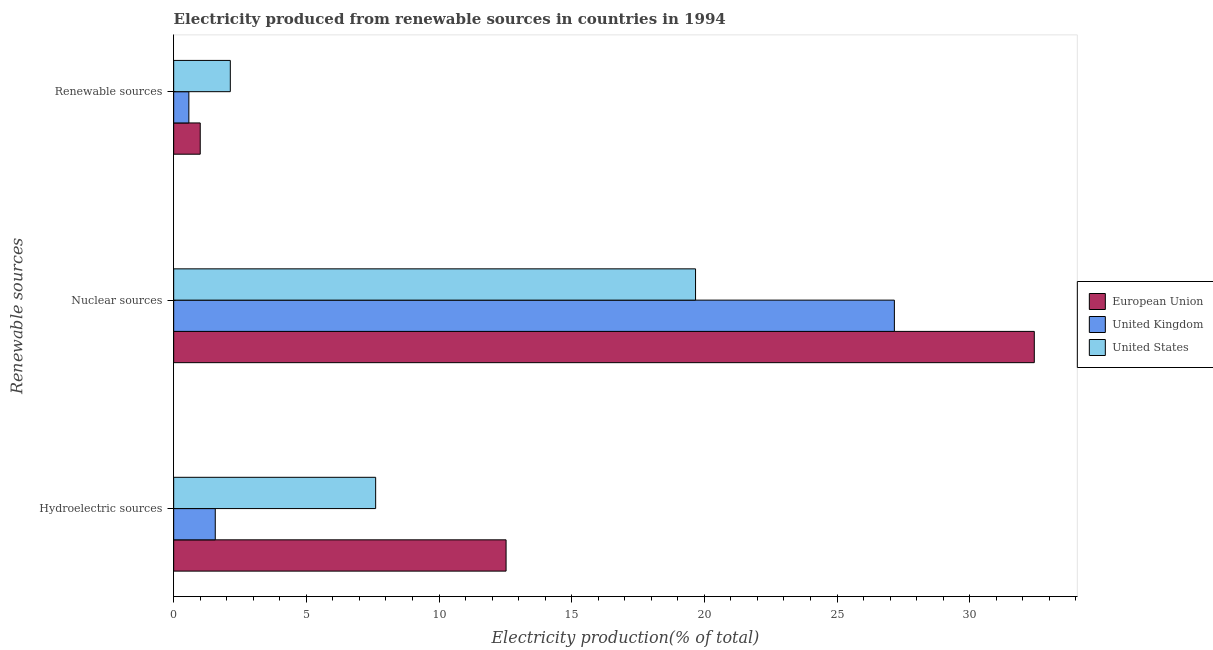How many bars are there on the 1st tick from the top?
Keep it short and to the point. 3. How many bars are there on the 1st tick from the bottom?
Your response must be concise. 3. What is the label of the 1st group of bars from the top?
Give a very brief answer. Renewable sources. What is the percentage of electricity produced by renewable sources in European Union?
Keep it short and to the point. 1. Across all countries, what is the maximum percentage of electricity produced by renewable sources?
Provide a succinct answer. 2.13. Across all countries, what is the minimum percentage of electricity produced by renewable sources?
Give a very brief answer. 0.57. In which country was the percentage of electricity produced by renewable sources maximum?
Your answer should be very brief. United States. What is the total percentage of electricity produced by nuclear sources in the graph?
Your answer should be compact. 79.27. What is the difference between the percentage of electricity produced by hydroelectric sources in United States and that in European Union?
Offer a very short reply. -4.92. What is the difference between the percentage of electricity produced by hydroelectric sources in United States and the percentage of electricity produced by renewable sources in United Kingdom?
Make the answer very short. 7.04. What is the average percentage of electricity produced by hydroelectric sources per country?
Your answer should be very brief. 7.24. What is the difference between the percentage of electricity produced by renewable sources and percentage of electricity produced by hydroelectric sources in United Kingdom?
Provide a succinct answer. -0.99. What is the ratio of the percentage of electricity produced by renewable sources in United States to that in European Union?
Your response must be concise. 2.13. What is the difference between the highest and the second highest percentage of electricity produced by hydroelectric sources?
Provide a short and direct response. 4.92. What is the difference between the highest and the lowest percentage of electricity produced by hydroelectric sources?
Your response must be concise. 10.96. What does the 3rd bar from the top in Nuclear sources represents?
Provide a succinct answer. European Union. What does the 2nd bar from the bottom in Nuclear sources represents?
Your response must be concise. United Kingdom. Are all the bars in the graph horizontal?
Make the answer very short. Yes. What is the difference between two consecutive major ticks on the X-axis?
Keep it short and to the point. 5. Are the values on the major ticks of X-axis written in scientific E-notation?
Offer a very short reply. No. Does the graph contain any zero values?
Ensure brevity in your answer.  No. How are the legend labels stacked?
Make the answer very short. Vertical. What is the title of the graph?
Your answer should be compact. Electricity produced from renewable sources in countries in 1994. Does "Iceland" appear as one of the legend labels in the graph?
Offer a terse response. No. What is the label or title of the Y-axis?
Your response must be concise. Renewable sources. What is the Electricity production(% of total) in European Union in Hydroelectric sources?
Provide a succinct answer. 12.53. What is the Electricity production(% of total) in United Kingdom in Hydroelectric sources?
Offer a terse response. 1.57. What is the Electricity production(% of total) in United States in Hydroelectric sources?
Provide a short and direct response. 7.61. What is the Electricity production(% of total) of European Union in Nuclear sources?
Provide a short and direct response. 32.44. What is the Electricity production(% of total) in United Kingdom in Nuclear sources?
Give a very brief answer. 27.16. What is the Electricity production(% of total) in United States in Nuclear sources?
Your response must be concise. 19.67. What is the Electricity production(% of total) in European Union in Renewable sources?
Provide a succinct answer. 1. What is the Electricity production(% of total) in United Kingdom in Renewable sources?
Your answer should be very brief. 0.57. What is the Electricity production(% of total) in United States in Renewable sources?
Provide a short and direct response. 2.13. Across all Renewable sources, what is the maximum Electricity production(% of total) in European Union?
Keep it short and to the point. 32.44. Across all Renewable sources, what is the maximum Electricity production(% of total) in United Kingdom?
Keep it short and to the point. 27.16. Across all Renewable sources, what is the maximum Electricity production(% of total) in United States?
Your response must be concise. 19.67. Across all Renewable sources, what is the minimum Electricity production(% of total) of European Union?
Provide a succinct answer. 1. Across all Renewable sources, what is the minimum Electricity production(% of total) in United Kingdom?
Make the answer very short. 0.57. Across all Renewable sources, what is the minimum Electricity production(% of total) in United States?
Give a very brief answer. 2.13. What is the total Electricity production(% of total) of European Union in the graph?
Ensure brevity in your answer.  45.96. What is the total Electricity production(% of total) of United Kingdom in the graph?
Offer a terse response. 29.3. What is the total Electricity production(% of total) of United States in the graph?
Your response must be concise. 29.42. What is the difference between the Electricity production(% of total) in European Union in Hydroelectric sources and that in Nuclear sources?
Ensure brevity in your answer.  -19.91. What is the difference between the Electricity production(% of total) of United Kingdom in Hydroelectric sources and that in Nuclear sources?
Offer a terse response. -25.59. What is the difference between the Electricity production(% of total) of United States in Hydroelectric sources and that in Nuclear sources?
Your response must be concise. -12.06. What is the difference between the Electricity production(% of total) in European Union in Hydroelectric sources and that in Renewable sources?
Keep it short and to the point. 11.53. What is the difference between the Electricity production(% of total) in United States in Hydroelectric sources and that in Renewable sources?
Your answer should be compact. 5.48. What is the difference between the Electricity production(% of total) in European Union in Nuclear sources and that in Renewable sources?
Offer a very short reply. 31.43. What is the difference between the Electricity production(% of total) of United Kingdom in Nuclear sources and that in Renewable sources?
Offer a very short reply. 26.59. What is the difference between the Electricity production(% of total) of United States in Nuclear sources and that in Renewable sources?
Give a very brief answer. 17.53. What is the difference between the Electricity production(% of total) of European Union in Hydroelectric sources and the Electricity production(% of total) of United Kingdom in Nuclear sources?
Offer a very short reply. -14.63. What is the difference between the Electricity production(% of total) of European Union in Hydroelectric sources and the Electricity production(% of total) of United States in Nuclear sources?
Offer a terse response. -7.14. What is the difference between the Electricity production(% of total) in United Kingdom in Hydroelectric sources and the Electricity production(% of total) in United States in Nuclear sources?
Provide a short and direct response. -18.1. What is the difference between the Electricity production(% of total) of European Union in Hydroelectric sources and the Electricity production(% of total) of United Kingdom in Renewable sources?
Your answer should be compact. 11.95. What is the difference between the Electricity production(% of total) of European Union in Hydroelectric sources and the Electricity production(% of total) of United States in Renewable sources?
Offer a very short reply. 10.39. What is the difference between the Electricity production(% of total) in United Kingdom in Hydroelectric sources and the Electricity production(% of total) in United States in Renewable sources?
Keep it short and to the point. -0.57. What is the difference between the Electricity production(% of total) in European Union in Nuclear sources and the Electricity production(% of total) in United Kingdom in Renewable sources?
Ensure brevity in your answer.  31.86. What is the difference between the Electricity production(% of total) in European Union in Nuclear sources and the Electricity production(% of total) in United States in Renewable sources?
Your response must be concise. 30.3. What is the difference between the Electricity production(% of total) of United Kingdom in Nuclear sources and the Electricity production(% of total) of United States in Renewable sources?
Offer a terse response. 25.03. What is the average Electricity production(% of total) in European Union per Renewable sources?
Your answer should be compact. 15.32. What is the average Electricity production(% of total) of United Kingdom per Renewable sources?
Give a very brief answer. 9.77. What is the average Electricity production(% of total) in United States per Renewable sources?
Offer a very short reply. 9.81. What is the difference between the Electricity production(% of total) in European Union and Electricity production(% of total) in United Kingdom in Hydroelectric sources?
Provide a succinct answer. 10.96. What is the difference between the Electricity production(% of total) of European Union and Electricity production(% of total) of United States in Hydroelectric sources?
Your response must be concise. 4.92. What is the difference between the Electricity production(% of total) of United Kingdom and Electricity production(% of total) of United States in Hydroelectric sources?
Your response must be concise. -6.05. What is the difference between the Electricity production(% of total) of European Union and Electricity production(% of total) of United Kingdom in Nuclear sources?
Make the answer very short. 5.27. What is the difference between the Electricity production(% of total) in European Union and Electricity production(% of total) in United States in Nuclear sources?
Provide a succinct answer. 12.77. What is the difference between the Electricity production(% of total) of United Kingdom and Electricity production(% of total) of United States in Nuclear sources?
Provide a short and direct response. 7.49. What is the difference between the Electricity production(% of total) in European Union and Electricity production(% of total) in United Kingdom in Renewable sources?
Provide a succinct answer. 0.43. What is the difference between the Electricity production(% of total) in European Union and Electricity production(% of total) in United States in Renewable sources?
Your response must be concise. -1.13. What is the difference between the Electricity production(% of total) of United Kingdom and Electricity production(% of total) of United States in Renewable sources?
Keep it short and to the point. -1.56. What is the ratio of the Electricity production(% of total) of European Union in Hydroelectric sources to that in Nuclear sources?
Your response must be concise. 0.39. What is the ratio of the Electricity production(% of total) in United Kingdom in Hydroelectric sources to that in Nuclear sources?
Make the answer very short. 0.06. What is the ratio of the Electricity production(% of total) in United States in Hydroelectric sources to that in Nuclear sources?
Your answer should be very brief. 0.39. What is the ratio of the Electricity production(% of total) in European Union in Hydroelectric sources to that in Renewable sources?
Offer a very short reply. 12.52. What is the ratio of the Electricity production(% of total) of United Kingdom in Hydroelectric sources to that in Renewable sources?
Offer a terse response. 2.74. What is the ratio of the Electricity production(% of total) of United States in Hydroelectric sources to that in Renewable sources?
Your answer should be compact. 3.57. What is the ratio of the Electricity production(% of total) in European Union in Nuclear sources to that in Renewable sources?
Make the answer very short. 32.41. What is the ratio of the Electricity production(% of total) of United Kingdom in Nuclear sources to that in Renewable sources?
Offer a terse response. 47.44. What is the ratio of the Electricity production(% of total) in United States in Nuclear sources to that in Renewable sources?
Your answer should be very brief. 9.21. What is the difference between the highest and the second highest Electricity production(% of total) of European Union?
Your answer should be very brief. 19.91. What is the difference between the highest and the second highest Electricity production(% of total) of United Kingdom?
Provide a succinct answer. 25.59. What is the difference between the highest and the second highest Electricity production(% of total) in United States?
Provide a short and direct response. 12.06. What is the difference between the highest and the lowest Electricity production(% of total) in European Union?
Provide a short and direct response. 31.43. What is the difference between the highest and the lowest Electricity production(% of total) in United Kingdom?
Give a very brief answer. 26.59. What is the difference between the highest and the lowest Electricity production(% of total) in United States?
Offer a terse response. 17.53. 